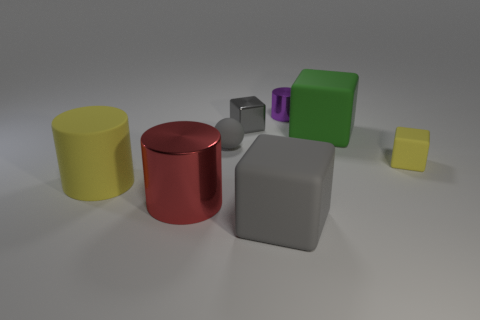Subtract all gray cubes. How many were subtracted if there are1gray cubes left? 1 Subtract 1 blocks. How many blocks are left? 3 Add 1 tiny purple cylinders. How many objects exist? 9 Subtract all cylinders. How many objects are left? 5 Add 2 green matte blocks. How many green matte blocks exist? 3 Subtract 0 green balls. How many objects are left? 8 Subtract all tiny yellow rubber things. Subtract all big things. How many objects are left? 3 Add 4 gray shiny cubes. How many gray shiny cubes are left? 5 